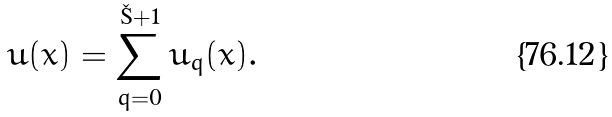<formula> <loc_0><loc_0><loc_500><loc_500>u ( x ) = \sum _ { q = 0 } ^ { \L + 1 } u _ { q } ( x ) .</formula> 